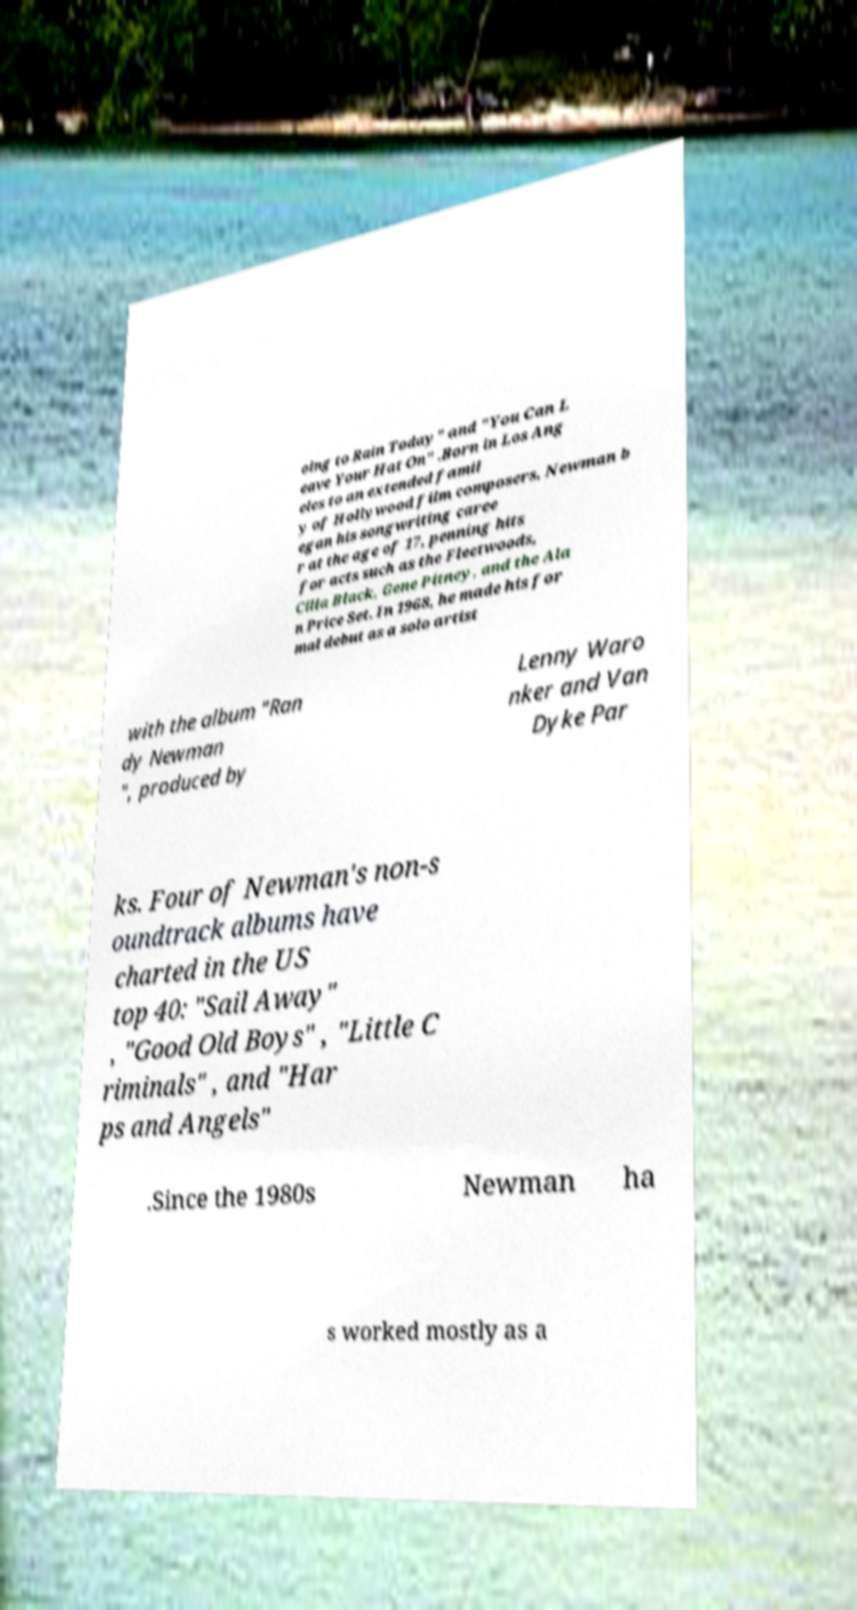Please read and relay the text visible in this image. What does it say? oing to Rain Today" and "You Can L eave Your Hat On" .Born in Los Ang eles to an extended famil y of Hollywood film composers, Newman b egan his songwriting caree r at the age of 17, penning hits for acts such as the Fleetwoods, Cilla Black, Gene Pitney, and the Ala n Price Set. In 1968, he made his for mal debut as a solo artist with the album "Ran dy Newman ", produced by Lenny Waro nker and Van Dyke Par ks. Four of Newman's non-s oundtrack albums have charted in the US top 40: "Sail Away" , "Good Old Boys" , "Little C riminals" , and "Har ps and Angels" .Since the 1980s Newman ha s worked mostly as a 